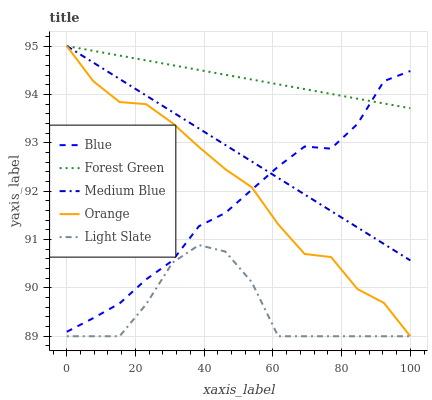Does Light Slate have the minimum area under the curve?
Answer yes or no. Yes. Does Forest Green have the maximum area under the curve?
Answer yes or no. Yes. Does Orange have the minimum area under the curve?
Answer yes or no. No. Does Orange have the maximum area under the curve?
Answer yes or no. No. Is Forest Green the smoothest?
Answer yes or no. Yes. Is Light Slate the roughest?
Answer yes or no. Yes. Is Orange the smoothest?
Answer yes or no. No. Is Orange the roughest?
Answer yes or no. No. Does Orange have the lowest value?
Answer yes or no. Yes. Does Forest Green have the lowest value?
Answer yes or no. No. Does Medium Blue have the highest value?
Answer yes or no. Yes. Does Light Slate have the highest value?
Answer yes or no. No. Is Light Slate less than Forest Green?
Answer yes or no. Yes. Is Medium Blue greater than Light Slate?
Answer yes or no. Yes. Does Forest Green intersect Medium Blue?
Answer yes or no. Yes. Is Forest Green less than Medium Blue?
Answer yes or no. No. Is Forest Green greater than Medium Blue?
Answer yes or no. No. Does Light Slate intersect Forest Green?
Answer yes or no. No. 